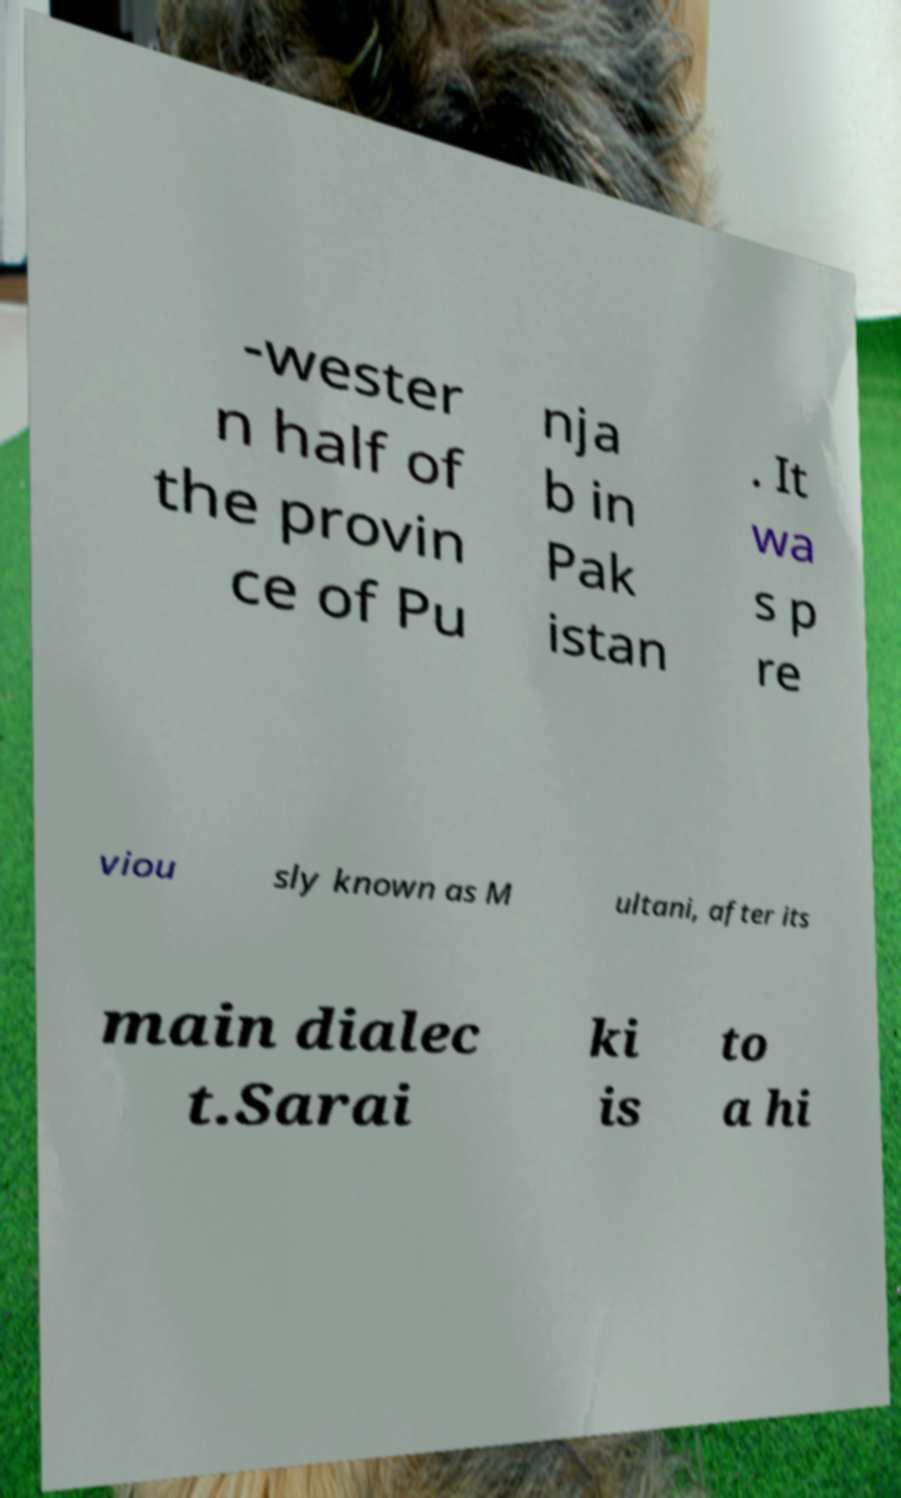Please read and relay the text visible in this image. What does it say? -wester n half of the provin ce of Pu nja b in Pak istan . It wa s p re viou sly known as M ultani, after its main dialec t.Sarai ki is to a hi 